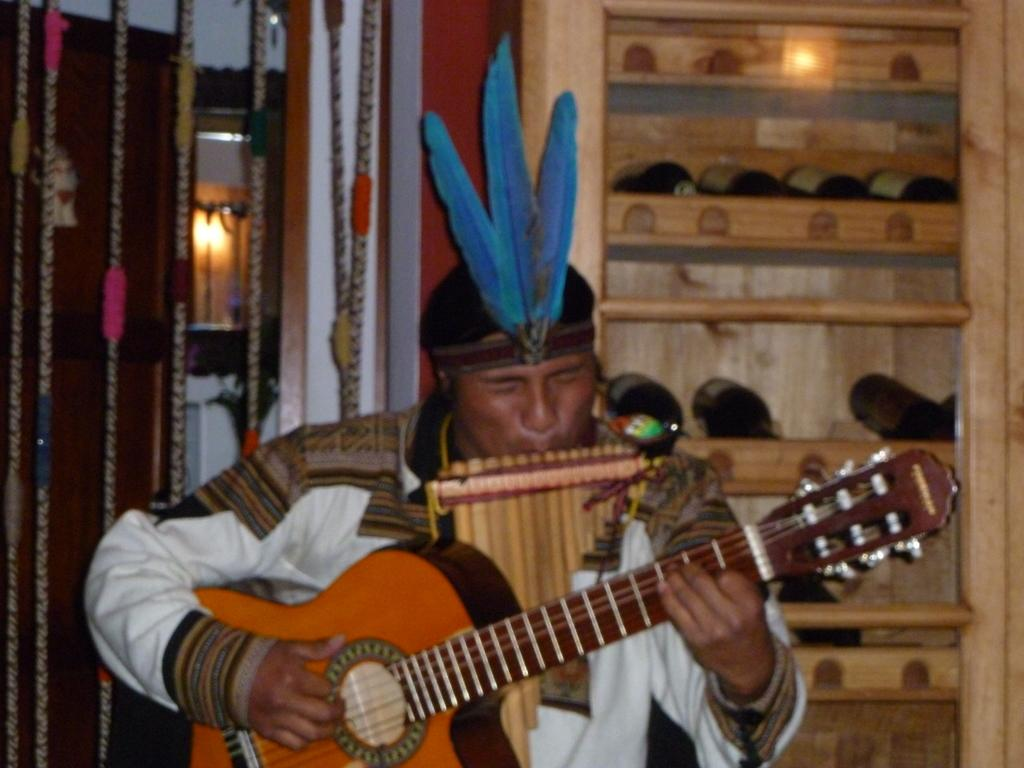What is the main subject of the image? There is a person in the image. What is the person wearing? The person is wearing a different costume. What is the person doing in the image? The person is playing a guitar. What can be seen in the background of the image? There are objects in shelves, a wall, and cupboards in the background of the image. What type of plantation can be seen in the background of the image? There is no plantation present in the image; the background features shelves, a wall, and cupboards. How does the person's stomach affect their ability to play the guitar in the image? The person's stomach is not mentioned in the image, and therefore its impact on their guitar playing cannot be determined. 